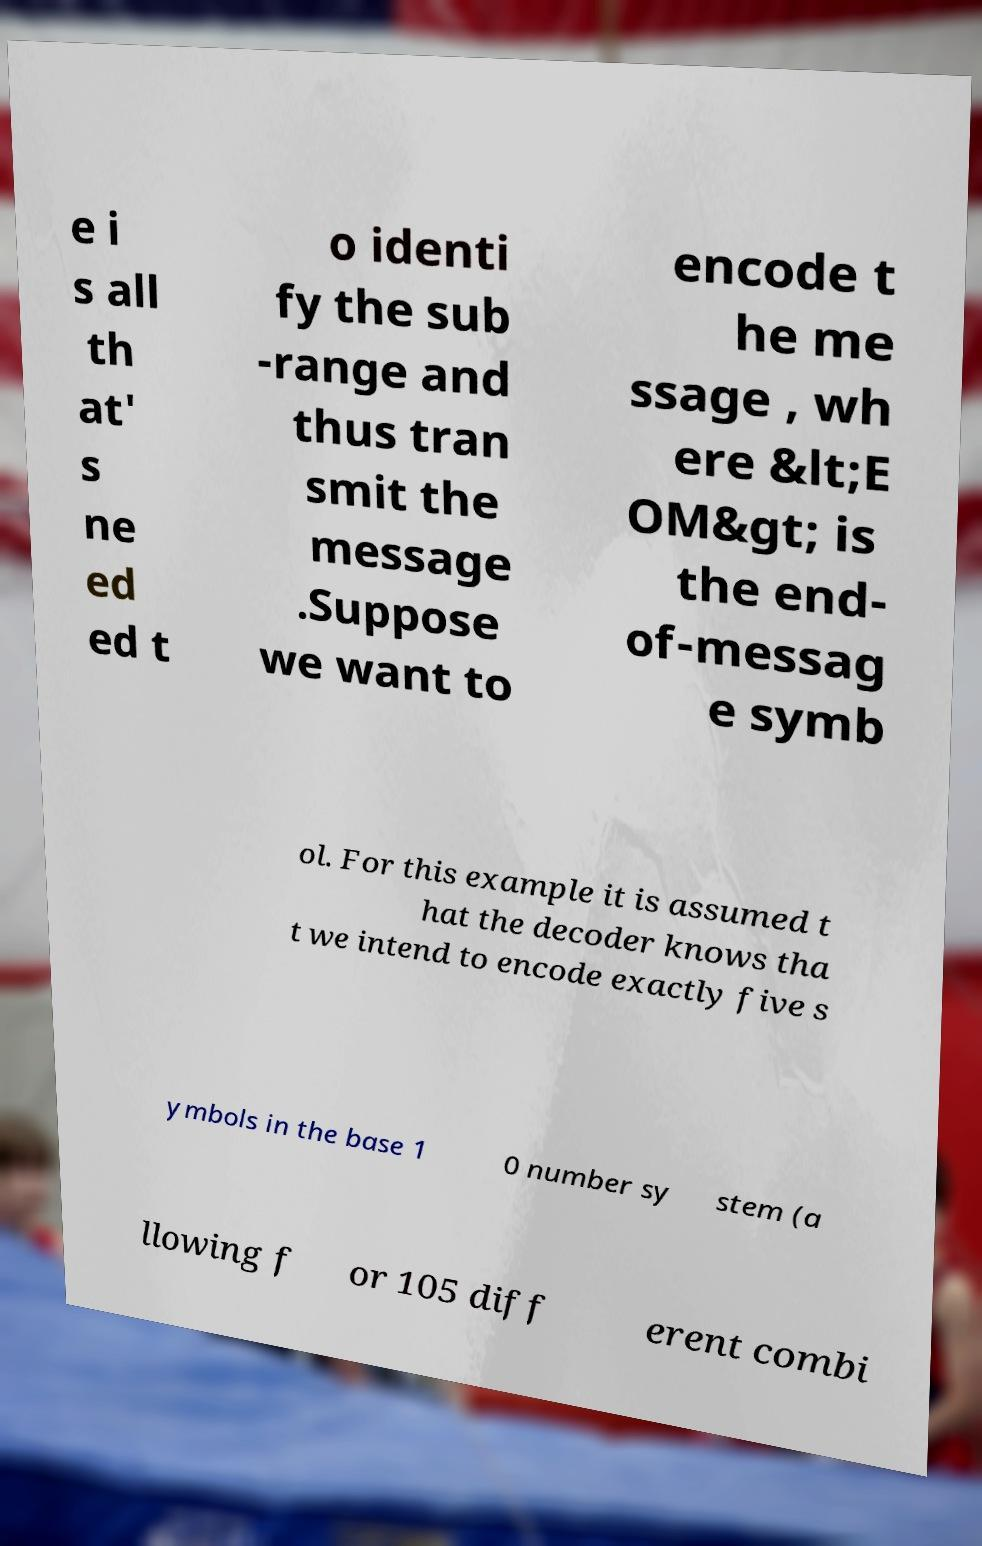Could you extract and type out the text from this image? e i s all th at' s ne ed ed t o identi fy the sub -range and thus tran smit the message .Suppose we want to encode t he me ssage , wh ere &lt;E OM&gt; is the end- of-messag e symb ol. For this example it is assumed t hat the decoder knows tha t we intend to encode exactly five s ymbols in the base 1 0 number sy stem (a llowing f or 105 diff erent combi 